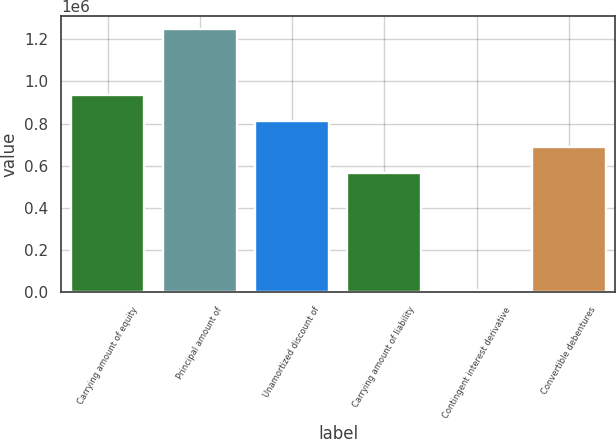Convert chart. <chart><loc_0><loc_0><loc_500><loc_500><bar_chart><fcel>Carrying amount of equity<fcel>Principal amount of<fcel>Unamortized discount of<fcel>Carrying amount of liability<fcel>Contingent interest derivative<fcel>Convertible debentures<nl><fcel>936378<fcel>1.25e+06<fcel>812378<fcel>564378<fcel>10000<fcel>688378<nl></chart> 